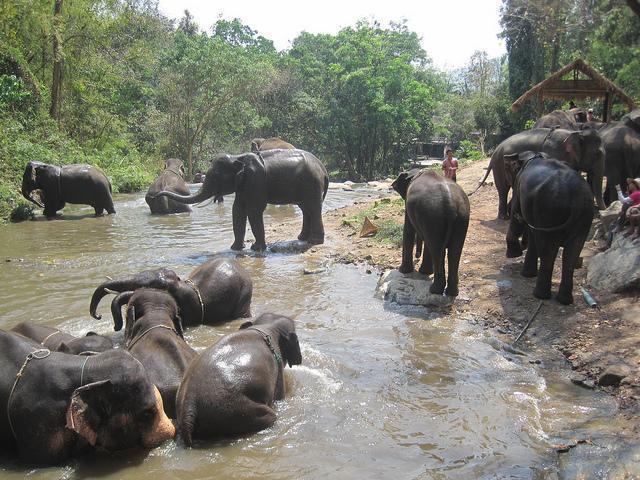How many elephants are there?
Give a very brief answer. 11. How many bikes are there?
Give a very brief answer. 0. 